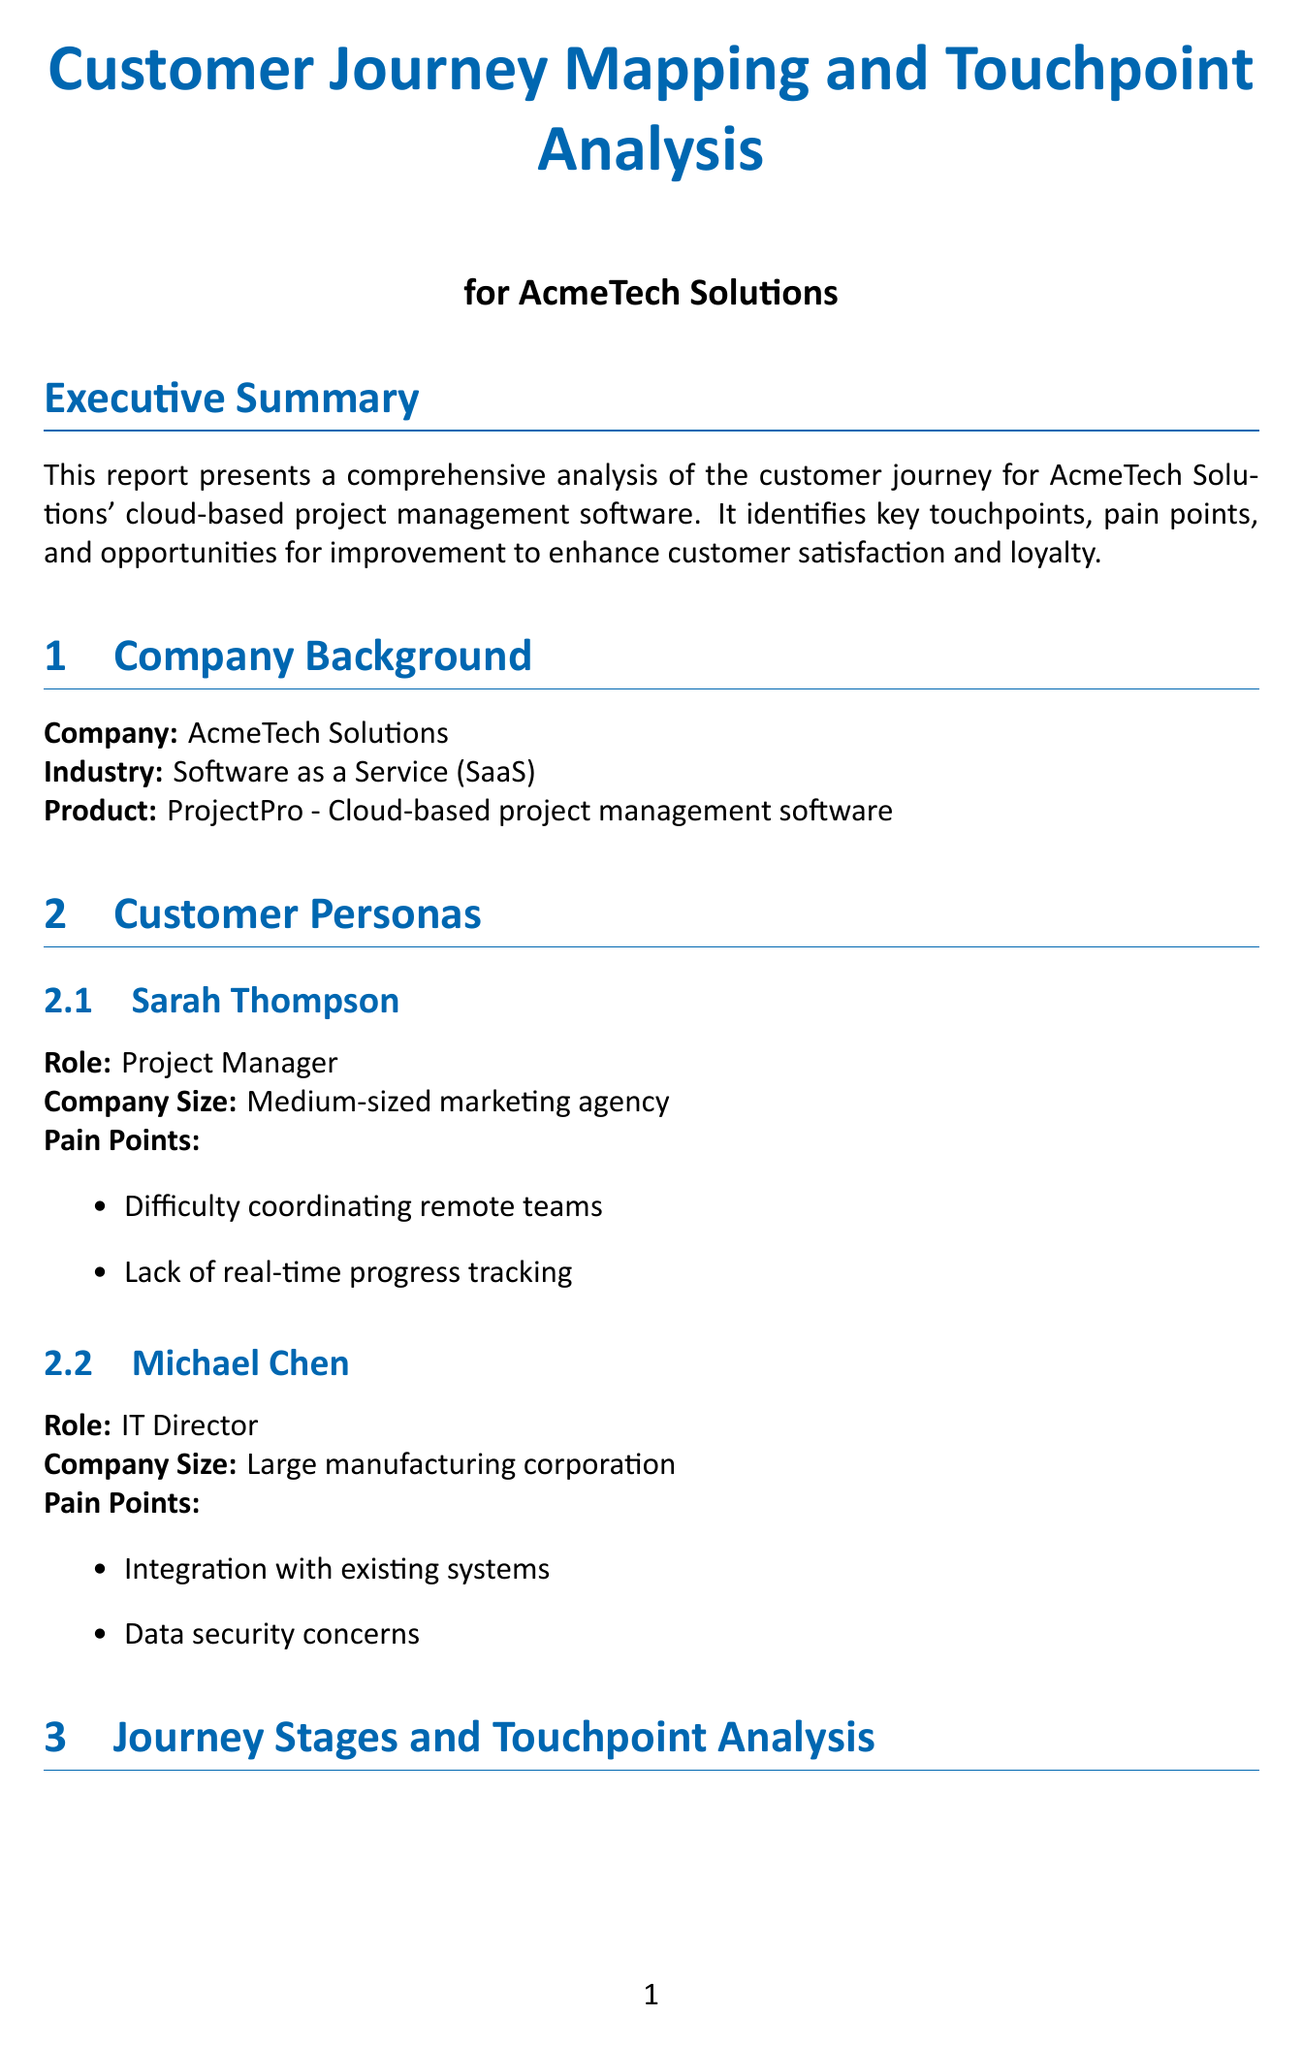What is the title of the report? The title of the report is provided in the document's header as the main focus.
Answer: Customer Journey Mapping and Touchpoint Analysis for AcmeTech Solutions Which company is the report about? The report details the background information of AcmeTech Solutions presented in the company background section.
Answer: AcmeTech Solutions What is Sarah Thompson's role? Sarah Thompson's role is found in the customer personas section, where individual roles are specified.
Answer: Project Manager What touchpoint in the Awareness stage has high effectiveness? The document lists the touchpoints and their effectiveness ratings during the Awareness stage.
Answer: Google Ads What is one improvement suggested for the online pricing calculator? The recommendations for the online pricing calculator are detailed under touchpoint analysis and improvement recommendations.
Answer: Redesign for better usability and clearer pricing tiers How many weeks of work are required to redesign the online pricing calculator? The expected duration for redesigning the online pricing calculator is specified in the resources required section.
Answer: 2-3 weeks of work What is the expected impact of implementing AI-driven personalization? The expected outcomes of implementing AI-driven personalization are outlined in the improvement recommendations section.
Answer: Improved feature adoption and user engagement What stage includes product demo webinars? The stages of the customer journey are segmented and specific touchpoints are classified under those stages.
Answer: Consideration What is the primary pain point for Michael Chen? Michael Chen's pain points are mentioned in the customer personas, indicating specific challenges he faces.
Answer: Integration with existing systems 